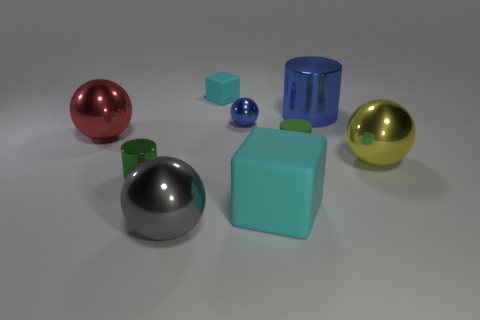Add 1 tiny cyan rubber cubes. How many objects exist? 10 Subtract all blocks. How many objects are left? 7 Subtract 1 yellow balls. How many objects are left? 8 Subtract all big gray objects. Subtract all tiny rubber things. How many objects are left? 6 Add 9 tiny matte cubes. How many tiny matte cubes are left? 10 Add 2 big yellow rubber objects. How many big yellow rubber objects exist? 2 